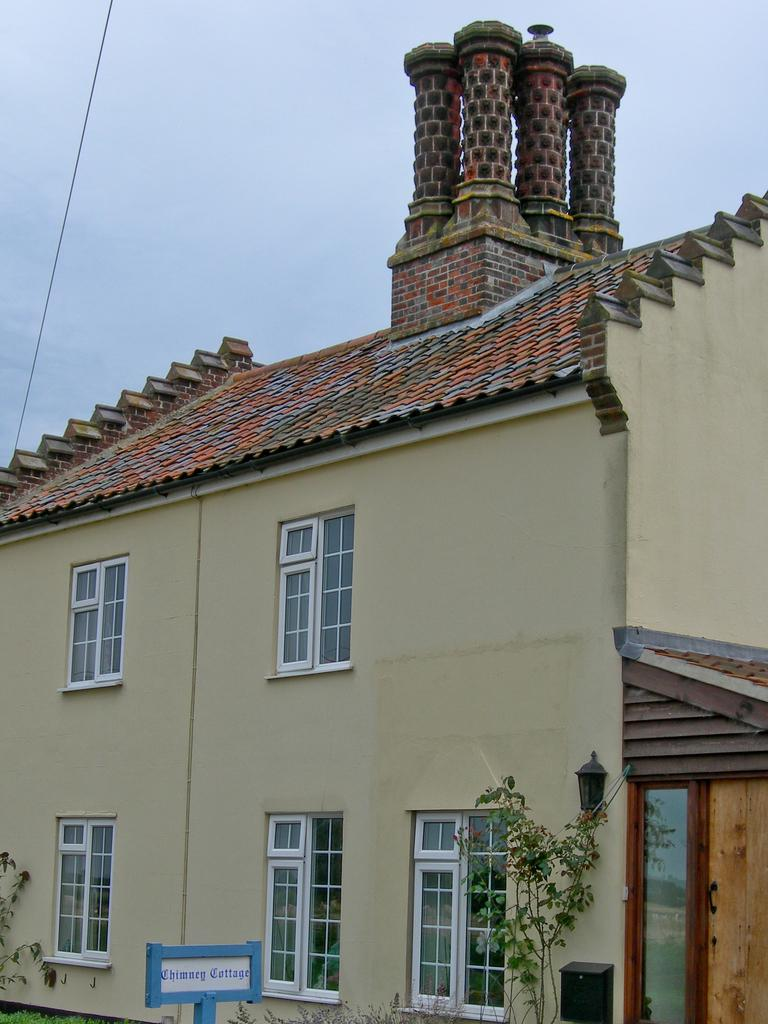What type of structure is present in the image? There is a building in the image. What is located at the bottom of the building? There are plants, a name board, and a post box at the bottom of the building. How many windows can be seen on the building? There are windows on the building. What is visible at the top of the image? The sky is visible at the top of the image, along with cables. What type of crime is being committed in the image? There is no indication of any crime being committed in the image. What is the position of the building in the image? The position of the building in the image cannot be determined without additional context or reference points. 